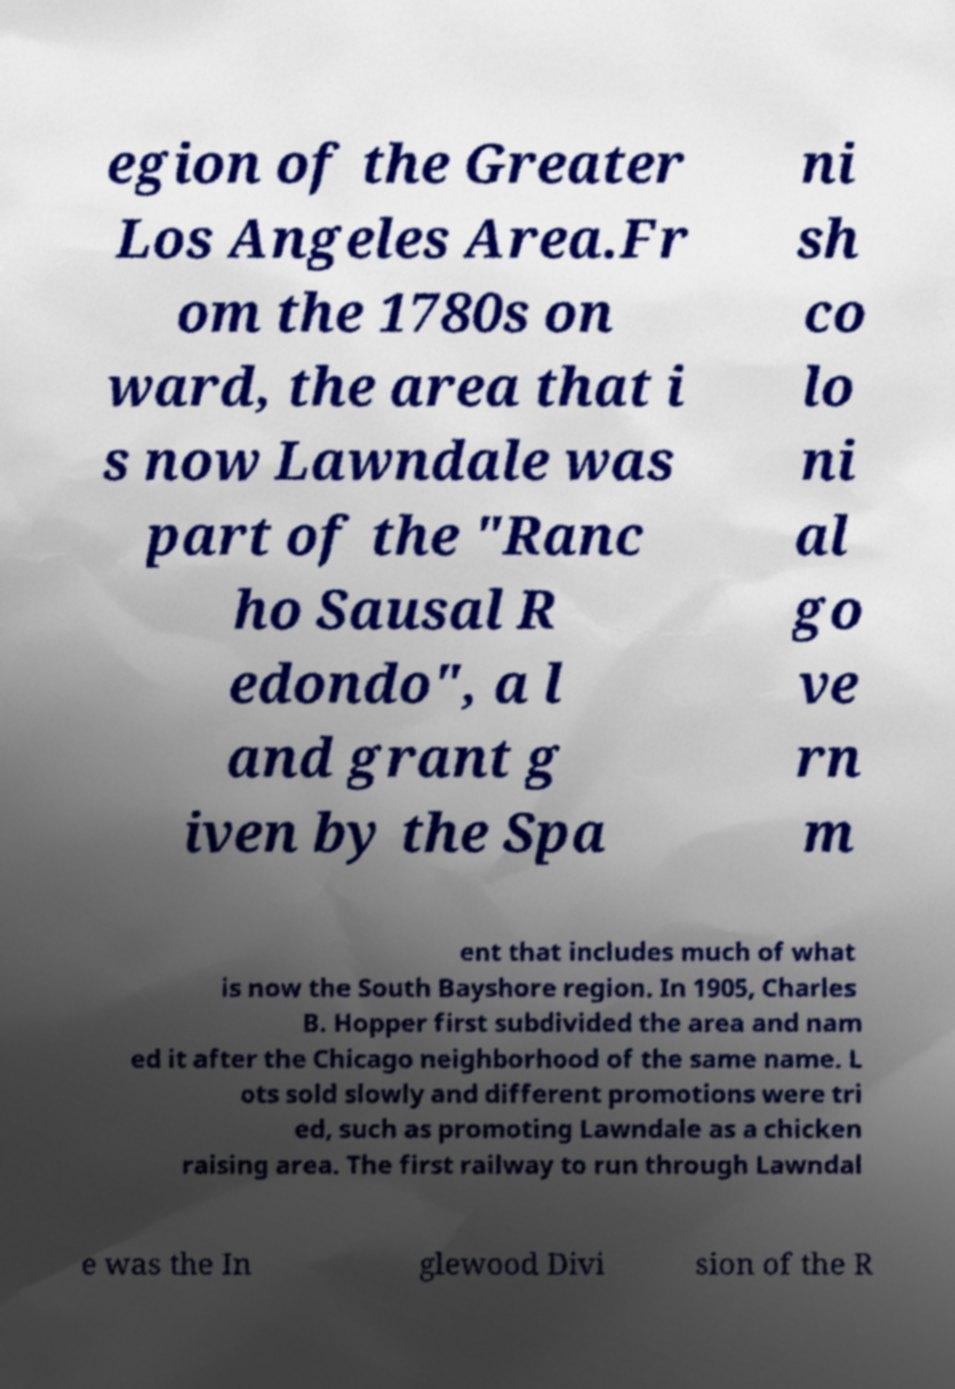There's text embedded in this image that I need extracted. Can you transcribe it verbatim? egion of the Greater Los Angeles Area.Fr om the 1780s on ward, the area that i s now Lawndale was part of the "Ranc ho Sausal R edondo", a l and grant g iven by the Spa ni sh co lo ni al go ve rn m ent that includes much of what is now the South Bayshore region. In 1905, Charles B. Hopper first subdivided the area and nam ed it after the Chicago neighborhood of the same name. L ots sold slowly and different promotions were tri ed, such as promoting Lawndale as a chicken raising area. The first railway to run through Lawndal e was the In glewood Divi sion of the R 